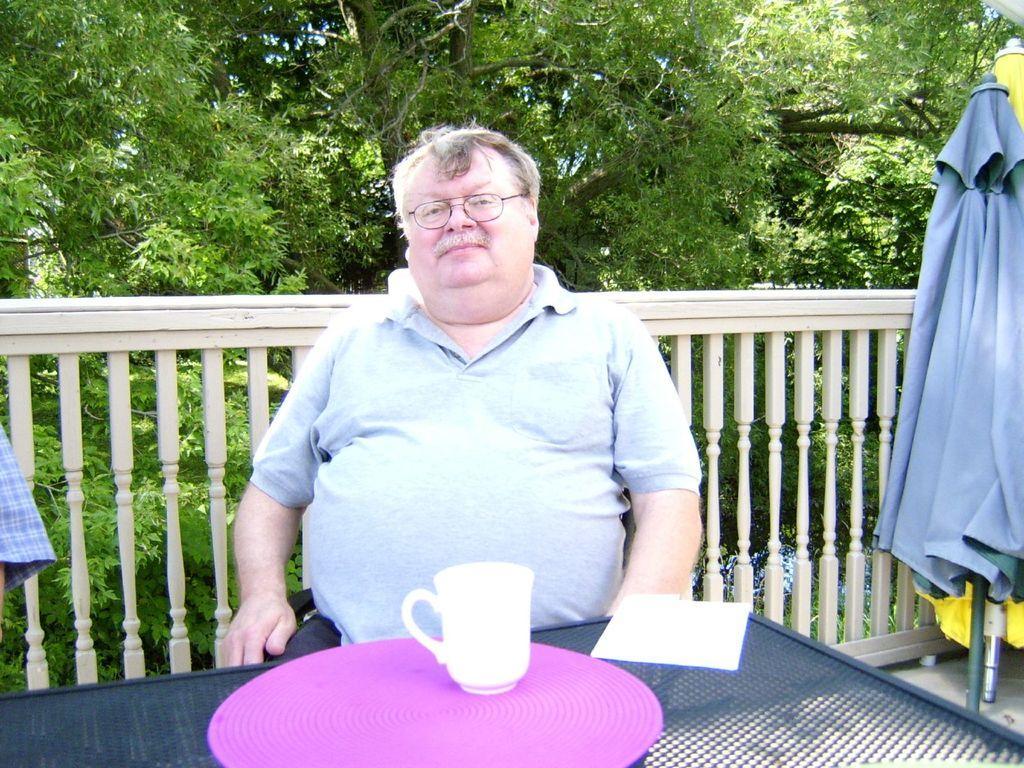How would you summarize this image in a sentence or two? The picture is taken in the balcony of a house. In the foreground of the picture there is a table, on the table there is a plate, a cup and a tissue paper. In the center of the picture there is a man sitting. In the center there is a railing and an umbrella. In the background there are trees. 